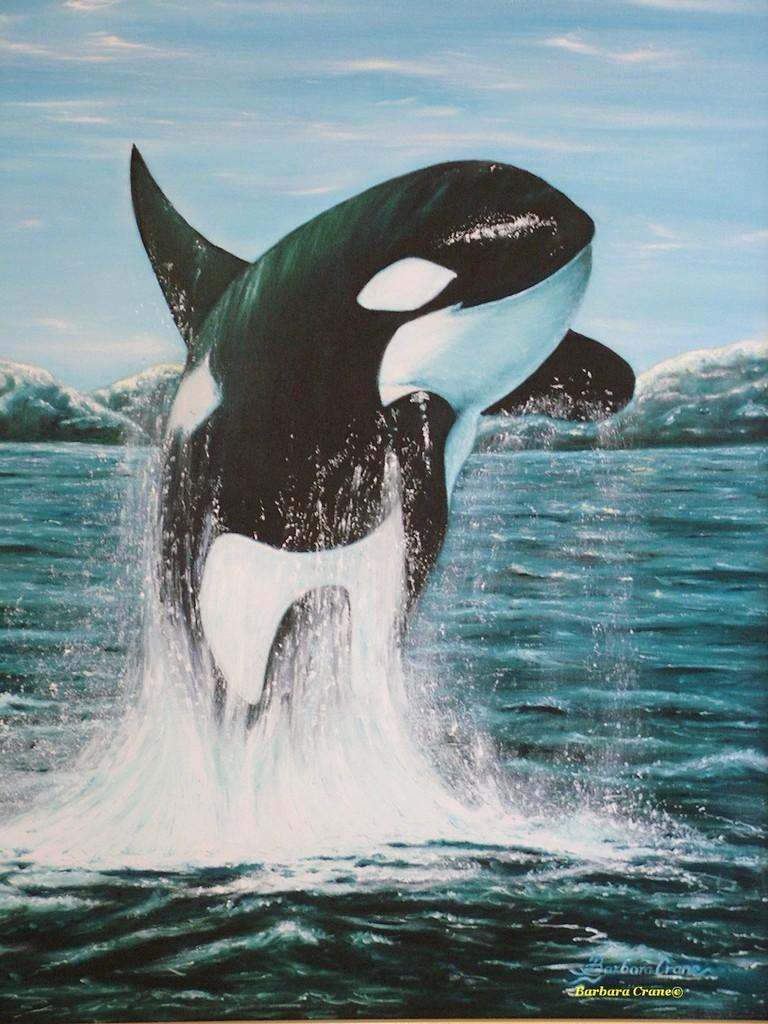Could you give a brief overview of what you see in this image? In this picture we can see one dolphin in the river. 